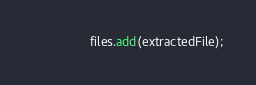<code> <loc_0><loc_0><loc_500><loc_500><_Java_>                files.add(extractedFile);</code> 